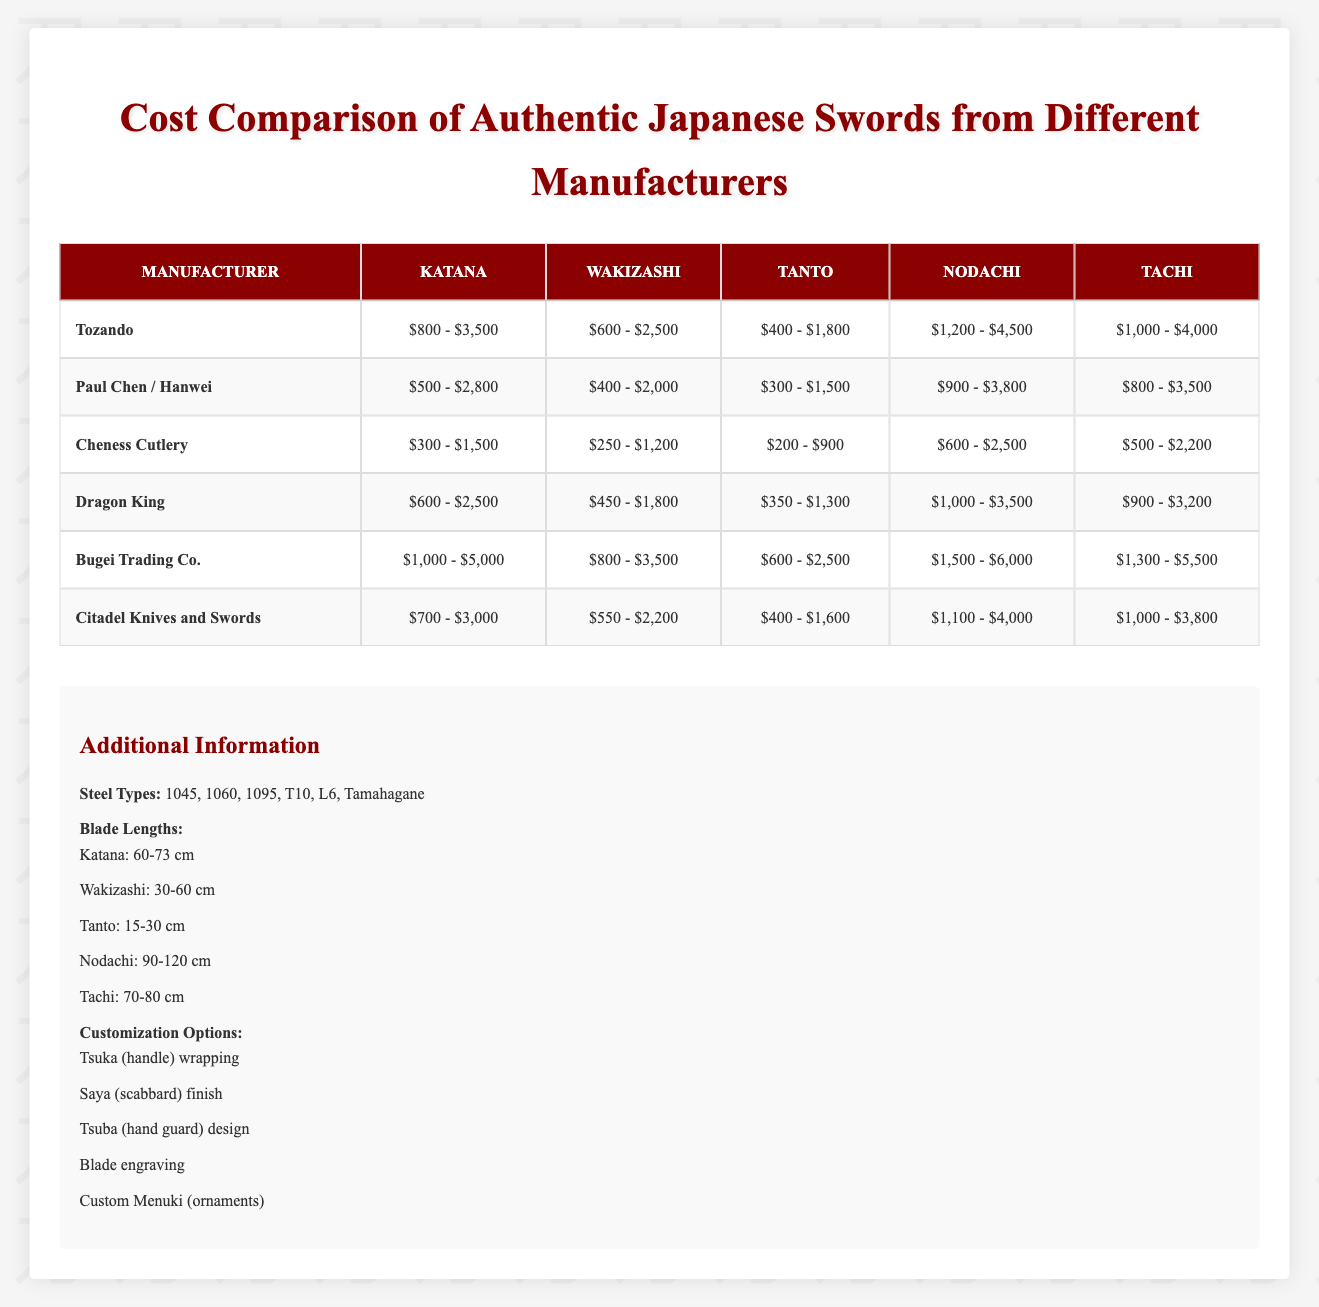What is the price range for a Katana from Bugei Trading Co.? According to the table, the price range for a Katana from Bugei Trading Co. is $1,000 - $5,000.
Answer: $1,000 - $5,000 What is the highest minimum price for a Wakizashi among the listed manufacturers? The minimum prices for Wakizashi are: Tozando ($600), Paul Chen / Hanwei ($400), Cheness Cutlery ($250), Dragon King ($450), Bugei Trading Co. ($800), and Citadel Knives and Swords ($550). The highest minimum price is $800 from Bugei Trading Co.
Answer: $800 Are Cheness Cutlery prices generally lower than those from Paul Chen / Hanwei? Reviewing the price ranges for each sword type, Cheness Cutlery has lower minimum prices in all categories: Katana ($300 vs. $500), Wakizashi ($250 vs. $400), Tanto ($200 vs. $300), Nodachi ($600 vs. $900), and Tachi ($500 vs. $800). Thus, it is true that Cheness Cutlery is generally lower.
Answer: Yes What is the average maximum price of a Tanto across all manufacturers? The maximum prices for Tanto are: Tozando ($1,800), Paul Chen / Hanwei ($1,500), Cheness Cutlery ($900), Dragon King ($1,300), Bugei Trading Co. ($2,500), and Citadel Knives and Swords ($1,600). Summing these gives $1,800 + $1,500 + $900 + $1,300 + $2,500 + $1,600 = $9,600. There are 6 manufacturers, thus the average is $9,600 / 6 = $1,600.
Answer: $1,600 Which manufacturer offers the most expensive Tachi and what is its price? In reviewing the Tachi price ranges from each manufacturer, Bugei Trading Co. has the highest price range with a maximum of $5,500. Therefore, Bugei Trading Co. offers the most expensive Tachi.
Answer: Bugei Trading Co. - $5,500 